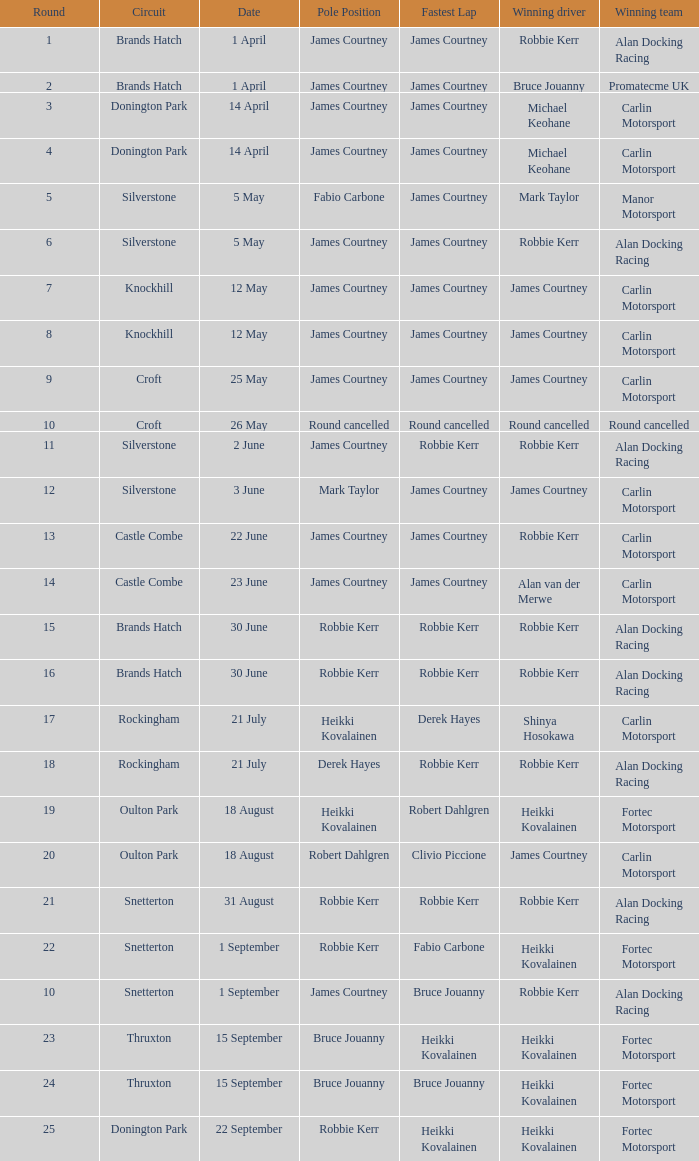Who are all winning drivers if winning team is Carlin Motorsport and circuit is Croft? James Courtney. 